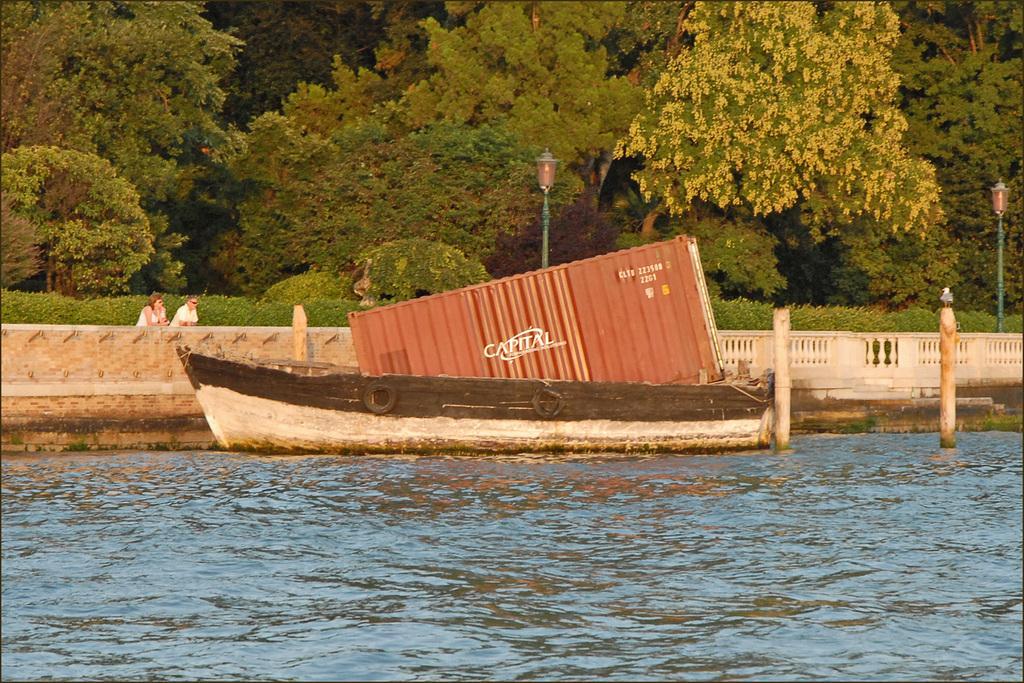How would you summarize this image in a sentence or two? In the image we can see the boat in the water and in the boat we can see the container. Here we can see the fence, poles, plants and trees. We can see there are even two people standing and they are wearing clothes. 